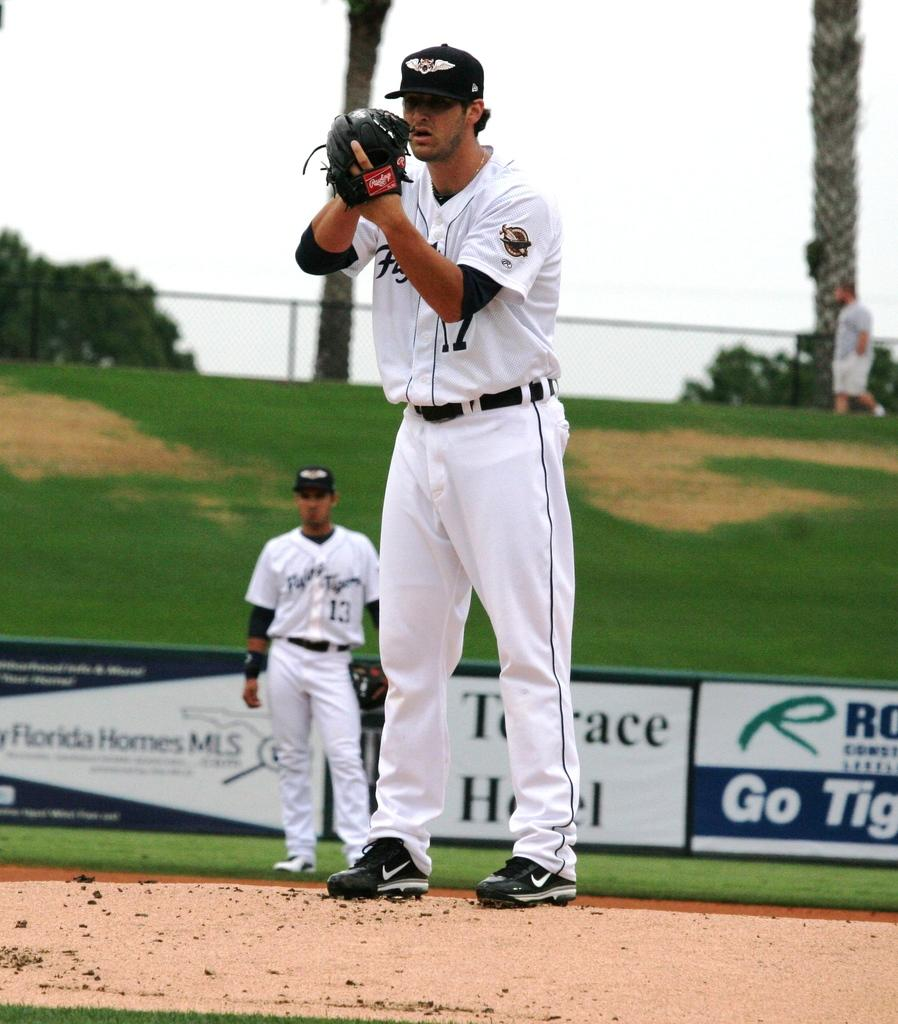How many people are present in the image? There are two people in the image. What are the people wearing? The people are wearing white dresses. Where are the people standing? The people are standing on the floor. What can be seen in the background of the image? There is a fencing and trees visible in the background. What type of pot is being used to create a border in the image? There is no pot or border present in the image. What town can be seen in the background of the image? The image does not show a town in the background; it only shows a fencing and trees. 